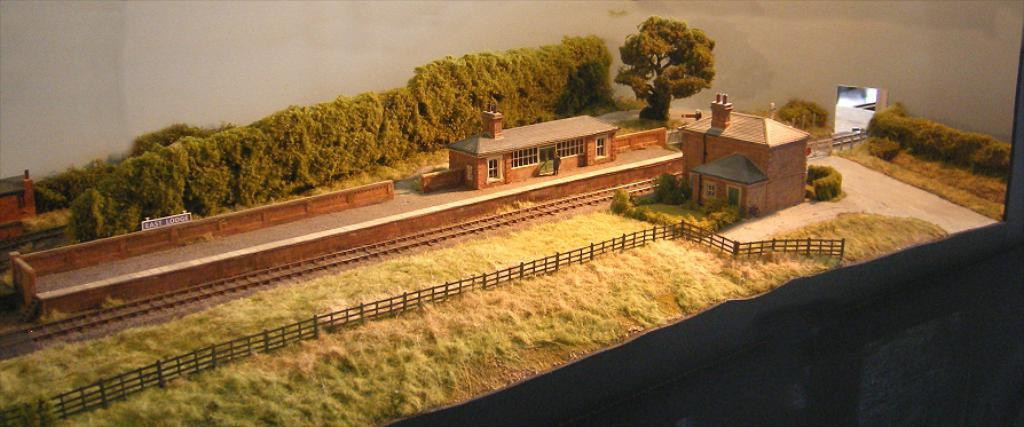What type of artwork is depicted in the image? The image is an art piece. What can be seen in the middle of the art piece? There are houses, a platform, a railway track, trees, a fence, and grass in the middle of the image. Are there any plants visible in the image? Yes, there are plants on the right side of the image. What type of terrain is present on the right side of the image? There is grass and land on the right side of the image. Is there any corn growing in the image? There is no corn visible in the image. Is it raining in the image? The image does not depict any rain or weather conditions. Can you see any agreements being signed in the image? There are no agreements or people signing documents present in the image. 